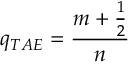Convert formula to latex. <formula><loc_0><loc_0><loc_500><loc_500>q _ { T A E } = \frac { m + \frac { 1 } { 2 } } { n }</formula> 